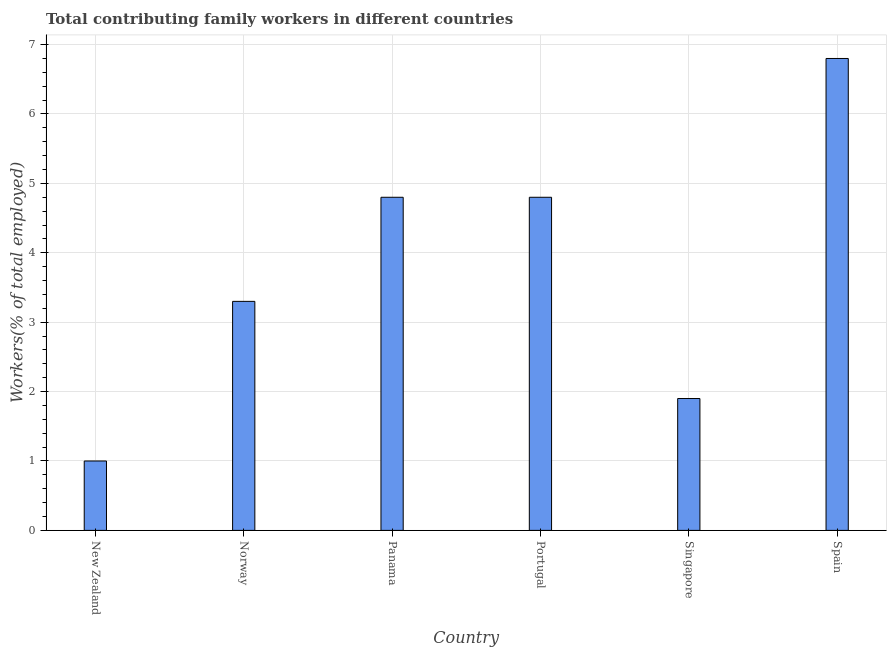Does the graph contain grids?
Provide a succinct answer. Yes. What is the title of the graph?
Provide a short and direct response. Total contributing family workers in different countries. What is the label or title of the Y-axis?
Offer a very short reply. Workers(% of total employed). What is the contributing family workers in Norway?
Your answer should be compact. 3.3. Across all countries, what is the maximum contributing family workers?
Provide a succinct answer. 6.8. Across all countries, what is the minimum contributing family workers?
Offer a terse response. 1. In which country was the contributing family workers minimum?
Ensure brevity in your answer.  New Zealand. What is the sum of the contributing family workers?
Make the answer very short. 22.6. What is the average contributing family workers per country?
Ensure brevity in your answer.  3.77. What is the median contributing family workers?
Offer a terse response. 4.05. In how many countries, is the contributing family workers greater than 1.4 %?
Provide a short and direct response. 5. What is the ratio of the contributing family workers in Panama to that in Singapore?
Your response must be concise. 2.53. Is the contributing family workers in Panama less than that in Portugal?
Give a very brief answer. No. Is the difference between the contributing family workers in Portugal and Singapore greater than the difference between any two countries?
Your answer should be compact. No. Is the sum of the contributing family workers in New Zealand and Singapore greater than the maximum contributing family workers across all countries?
Keep it short and to the point. No. What is the difference between the highest and the lowest contributing family workers?
Keep it short and to the point. 5.8. In how many countries, is the contributing family workers greater than the average contributing family workers taken over all countries?
Make the answer very short. 3. Are all the bars in the graph horizontal?
Offer a very short reply. No. What is the difference between two consecutive major ticks on the Y-axis?
Your answer should be very brief. 1. Are the values on the major ticks of Y-axis written in scientific E-notation?
Provide a succinct answer. No. What is the Workers(% of total employed) in New Zealand?
Provide a succinct answer. 1. What is the Workers(% of total employed) of Norway?
Your response must be concise. 3.3. What is the Workers(% of total employed) in Panama?
Provide a succinct answer. 4.8. What is the Workers(% of total employed) of Portugal?
Your answer should be compact. 4.8. What is the Workers(% of total employed) in Singapore?
Provide a succinct answer. 1.9. What is the Workers(% of total employed) of Spain?
Give a very brief answer. 6.8. What is the difference between the Workers(% of total employed) in New Zealand and Norway?
Offer a very short reply. -2.3. What is the difference between the Workers(% of total employed) in New Zealand and Panama?
Provide a short and direct response. -3.8. What is the difference between the Workers(% of total employed) in New Zealand and Portugal?
Offer a very short reply. -3.8. What is the difference between the Workers(% of total employed) in New Zealand and Spain?
Your answer should be compact. -5.8. What is the difference between the Workers(% of total employed) in Norway and Panama?
Your answer should be compact. -1.5. What is the difference between the Workers(% of total employed) in Norway and Portugal?
Provide a short and direct response. -1.5. What is the difference between the Workers(% of total employed) in Panama and Singapore?
Ensure brevity in your answer.  2.9. What is the difference between the Workers(% of total employed) in Panama and Spain?
Your response must be concise. -2. What is the difference between the Workers(% of total employed) in Portugal and Spain?
Your answer should be compact. -2. What is the difference between the Workers(% of total employed) in Singapore and Spain?
Your answer should be compact. -4.9. What is the ratio of the Workers(% of total employed) in New Zealand to that in Norway?
Keep it short and to the point. 0.3. What is the ratio of the Workers(% of total employed) in New Zealand to that in Panama?
Offer a very short reply. 0.21. What is the ratio of the Workers(% of total employed) in New Zealand to that in Portugal?
Your answer should be compact. 0.21. What is the ratio of the Workers(% of total employed) in New Zealand to that in Singapore?
Offer a terse response. 0.53. What is the ratio of the Workers(% of total employed) in New Zealand to that in Spain?
Your answer should be compact. 0.15. What is the ratio of the Workers(% of total employed) in Norway to that in Panama?
Your answer should be very brief. 0.69. What is the ratio of the Workers(% of total employed) in Norway to that in Portugal?
Offer a very short reply. 0.69. What is the ratio of the Workers(% of total employed) in Norway to that in Singapore?
Provide a short and direct response. 1.74. What is the ratio of the Workers(% of total employed) in Norway to that in Spain?
Your answer should be very brief. 0.48. What is the ratio of the Workers(% of total employed) in Panama to that in Portugal?
Give a very brief answer. 1. What is the ratio of the Workers(% of total employed) in Panama to that in Singapore?
Offer a very short reply. 2.53. What is the ratio of the Workers(% of total employed) in Panama to that in Spain?
Offer a very short reply. 0.71. What is the ratio of the Workers(% of total employed) in Portugal to that in Singapore?
Offer a terse response. 2.53. What is the ratio of the Workers(% of total employed) in Portugal to that in Spain?
Provide a short and direct response. 0.71. What is the ratio of the Workers(% of total employed) in Singapore to that in Spain?
Your answer should be compact. 0.28. 